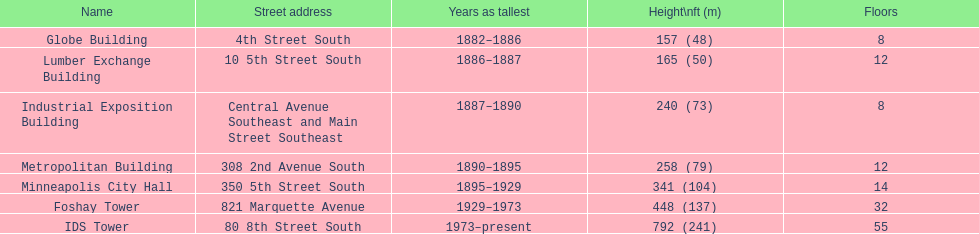Write the full table. {'header': ['Name', 'Street address', 'Years as tallest', 'Height\\nft (m)', 'Floors'], 'rows': [['Globe Building', '4th Street South', '1882–1886', '157 (48)', '8'], ['Lumber Exchange Building', '10 5th Street South', '1886–1887', '165 (50)', '12'], ['Industrial Exposition Building', 'Central Avenue Southeast and Main Street Southeast', '1887–1890', '240 (73)', '8'], ['Metropolitan Building', '308 2nd Avenue South', '1890–1895', '258 (79)', '12'], ['Minneapolis City Hall', '350 5th Street South', '1895–1929', '341 (104)', '14'], ['Foshay Tower', '821 Marquette Avenue', '1929–1973', '448 (137)', '32'], ['IDS Tower', '80 8th Street South', '1973–present', '792 (241)', '55']]} Identify the highest building. IDS Tower. 